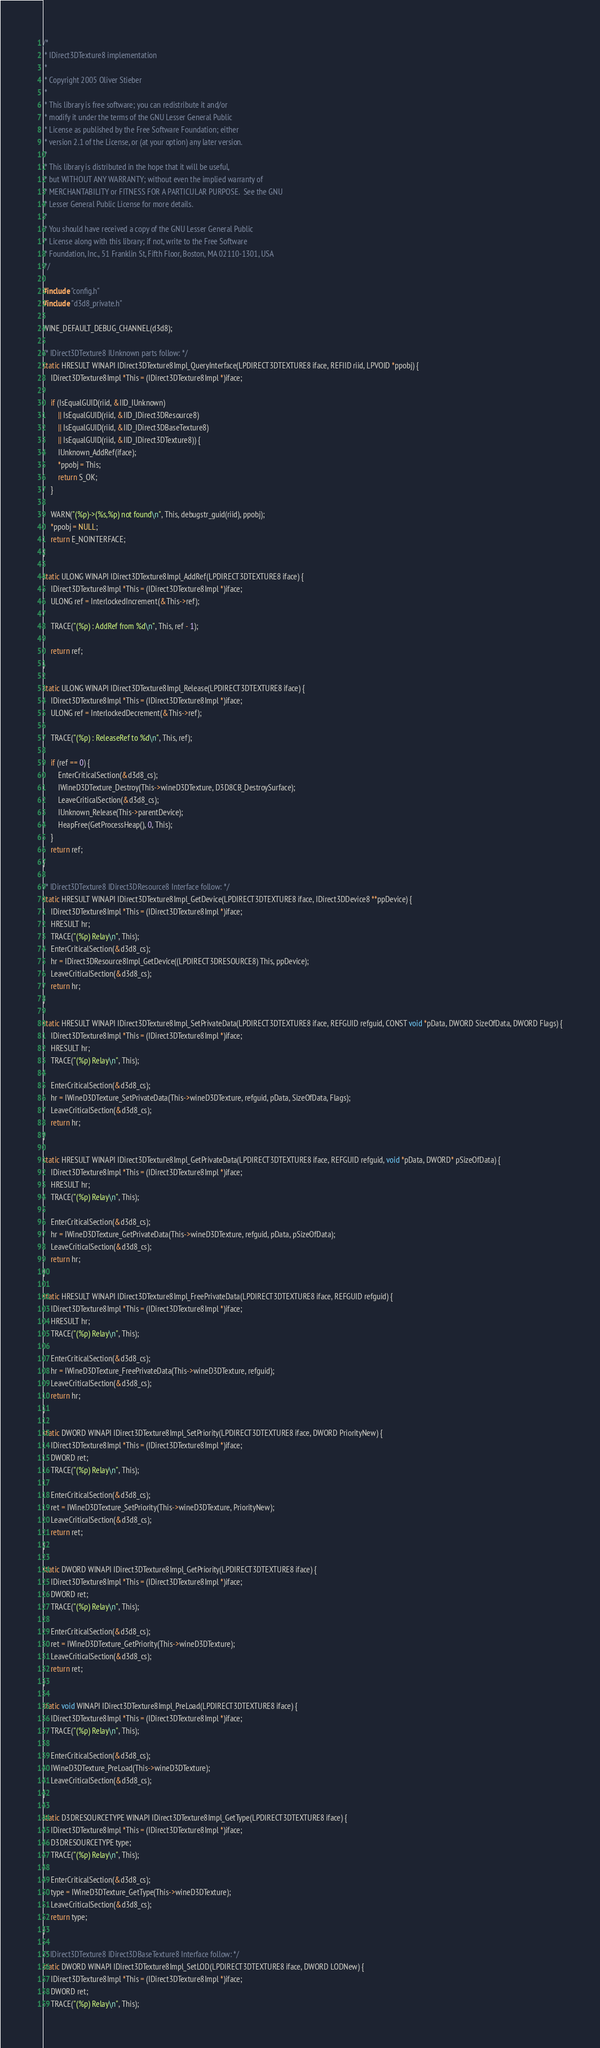Convert code to text. <code><loc_0><loc_0><loc_500><loc_500><_C_>/*
 * IDirect3DTexture8 implementation
 *
 * Copyright 2005 Oliver Stieber
 *
 * This library is free software; you can redistribute it and/or
 * modify it under the terms of the GNU Lesser General Public
 * License as published by the Free Software Foundation; either
 * version 2.1 of the License, or (at your option) any later version.
 *
 * This library is distributed in the hope that it will be useful,
 * but WITHOUT ANY WARRANTY; without even the implied warranty of
 * MERCHANTABILITY or FITNESS FOR A PARTICULAR PURPOSE.  See the GNU
 * Lesser General Public License for more details.
 *
 * You should have received a copy of the GNU Lesser General Public
 * License along with this library; if not, write to the Free Software
 * Foundation, Inc., 51 Franklin St, Fifth Floor, Boston, MA 02110-1301, USA
 */

#include "config.h"
#include "d3d8_private.h"

WINE_DEFAULT_DEBUG_CHANNEL(d3d8);

/* IDirect3DTexture8 IUnknown parts follow: */
static HRESULT WINAPI IDirect3DTexture8Impl_QueryInterface(LPDIRECT3DTEXTURE8 iface, REFIID riid, LPVOID *ppobj) {
    IDirect3DTexture8Impl *This = (IDirect3DTexture8Impl *)iface;

    if (IsEqualGUID(riid, &IID_IUnknown)
        || IsEqualGUID(riid, &IID_IDirect3DResource8)
        || IsEqualGUID(riid, &IID_IDirect3DBaseTexture8)
        || IsEqualGUID(riid, &IID_IDirect3DTexture8)) {
        IUnknown_AddRef(iface);
        *ppobj = This;
        return S_OK;
    }

    WARN("(%p)->(%s,%p) not found\n", This, debugstr_guid(riid), ppobj);
    *ppobj = NULL;
    return E_NOINTERFACE;
}

static ULONG WINAPI IDirect3DTexture8Impl_AddRef(LPDIRECT3DTEXTURE8 iface) {
    IDirect3DTexture8Impl *This = (IDirect3DTexture8Impl *)iface;
    ULONG ref = InterlockedIncrement(&This->ref);

    TRACE("(%p) : AddRef from %d\n", This, ref - 1);

    return ref;
}

static ULONG WINAPI IDirect3DTexture8Impl_Release(LPDIRECT3DTEXTURE8 iface) {
    IDirect3DTexture8Impl *This = (IDirect3DTexture8Impl *)iface;
    ULONG ref = InterlockedDecrement(&This->ref);

    TRACE("(%p) : ReleaseRef to %d\n", This, ref);

    if (ref == 0) {
        EnterCriticalSection(&d3d8_cs);
        IWineD3DTexture_Destroy(This->wineD3DTexture, D3D8CB_DestroySurface);
        LeaveCriticalSection(&d3d8_cs);
        IUnknown_Release(This->parentDevice);
        HeapFree(GetProcessHeap(), 0, This);
    }
    return ref;
}

/* IDirect3DTexture8 IDirect3DResource8 Interface follow: */
static HRESULT WINAPI IDirect3DTexture8Impl_GetDevice(LPDIRECT3DTEXTURE8 iface, IDirect3DDevice8 **ppDevice) {
    IDirect3DTexture8Impl *This = (IDirect3DTexture8Impl *)iface;
    HRESULT hr;
    TRACE("(%p) Relay\n", This);
    EnterCriticalSection(&d3d8_cs);
    hr = IDirect3DResource8Impl_GetDevice((LPDIRECT3DRESOURCE8) This, ppDevice);
    LeaveCriticalSection(&d3d8_cs);
    return hr;
}

static HRESULT WINAPI IDirect3DTexture8Impl_SetPrivateData(LPDIRECT3DTEXTURE8 iface, REFGUID refguid, CONST void *pData, DWORD SizeOfData, DWORD Flags) {
    IDirect3DTexture8Impl *This = (IDirect3DTexture8Impl *)iface;
    HRESULT hr;
    TRACE("(%p) Relay\n", This);

    EnterCriticalSection(&d3d8_cs);
    hr = IWineD3DTexture_SetPrivateData(This->wineD3DTexture, refguid, pData, SizeOfData, Flags);
    LeaveCriticalSection(&d3d8_cs);
    return hr;
}

static HRESULT WINAPI IDirect3DTexture8Impl_GetPrivateData(LPDIRECT3DTEXTURE8 iface, REFGUID refguid, void *pData, DWORD* pSizeOfData) {
    IDirect3DTexture8Impl *This = (IDirect3DTexture8Impl *)iface;
    HRESULT hr;
    TRACE("(%p) Relay\n", This);

    EnterCriticalSection(&d3d8_cs);
    hr = IWineD3DTexture_GetPrivateData(This->wineD3DTexture, refguid, pData, pSizeOfData);
    LeaveCriticalSection(&d3d8_cs);
    return hr;
}

static HRESULT WINAPI IDirect3DTexture8Impl_FreePrivateData(LPDIRECT3DTEXTURE8 iface, REFGUID refguid) {
    IDirect3DTexture8Impl *This = (IDirect3DTexture8Impl *)iface;
    HRESULT hr;
    TRACE("(%p) Relay\n", This);

    EnterCriticalSection(&d3d8_cs);
    hr = IWineD3DTexture_FreePrivateData(This->wineD3DTexture, refguid);
    LeaveCriticalSection(&d3d8_cs);
    return hr;
}

static DWORD WINAPI IDirect3DTexture8Impl_SetPriority(LPDIRECT3DTEXTURE8 iface, DWORD PriorityNew) {
    IDirect3DTexture8Impl *This = (IDirect3DTexture8Impl *)iface;
    DWORD ret;
    TRACE("(%p) Relay\n", This);

    EnterCriticalSection(&d3d8_cs);
    ret = IWineD3DTexture_SetPriority(This->wineD3DTexture, PriorityNew);
    LeaveCriticalSection(&d3d8_cs);
    return ret;
}

static DWORD WINAPI IDirect3DTexture8Impl_GetPriority(LPDIRECT3DTEXTURE8 iface) {
    IDirect3DTexture8Impl *This = (IDirect3DTexture8Impl *)iface;
    DWORD ret;
    TRACE("(%p) Relay\n", This);

    EnterCriticalSection(&d3d8_cs);
    ret = IWineD3DTexture_GetPriority(This->wineD3DTexture);
    LeaveCriticalSection(&d3d8_cs);
    return ret;
}

static void WINAPI IDirect3DTexture8Impl_PreLoad(LPDIRECT3DTEXTURE8 iface) {
    IDirect3DTexture8Impl *This = (IDirect3DTexture8Impl *)iface;
    TRACE("(%p) Relay\n", This);

    EnterCriticalSection(&d3d8_cs);
    IWineD3DTexture_PreLoad(This->wineD3DTexture);
    LeaveCriticalSection(&d3d8_cs);
}

static D3DRESOURCETYPE WINAPI IDirect3DTexture8Impl_GetType(LPDIRECT3DTEXTURE8 iface) {
    IDirect3DTexture8Impl *This = (IDirect3DTexture8Impl *)iface;
    D3DRESOURCETYPE type;
    TRACE("(%p) Relay\n", This);

    EnterCriticalSection(&d3d8_cs);
    type = IWineD3DTexture_GetType(This->wineD3DTexture);
    LeaveCriticalSection(&d3d8_cs);
    return type;
}

/* IDirect3DTexture8 IDirect3DBaseTexture8 Interface follow: */
static DWORD WINAPI IDirect3DTexture8Impl_SetLOD(LPDIRECT3DTEXTURE8 iface, DWORD LODNew) {
    IDirect3DTexture8Impl *This = (IDirect3DTexture8Impl *)iface;
    DWORD ret;
    TRACE("(%p) Relay\n", This);
</code> 